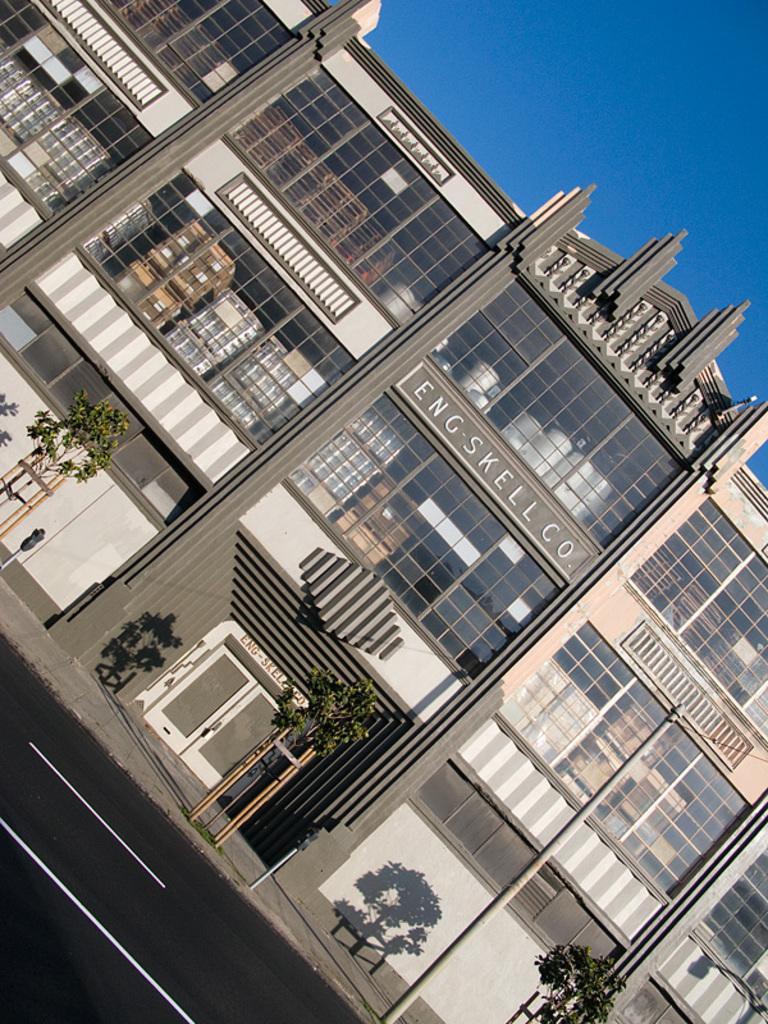In one or two sentences, can you explain what this image depicts? In this picture we can observe a building. There are some small trees in front of this building. There is a road. In the background we can observe a sky. 